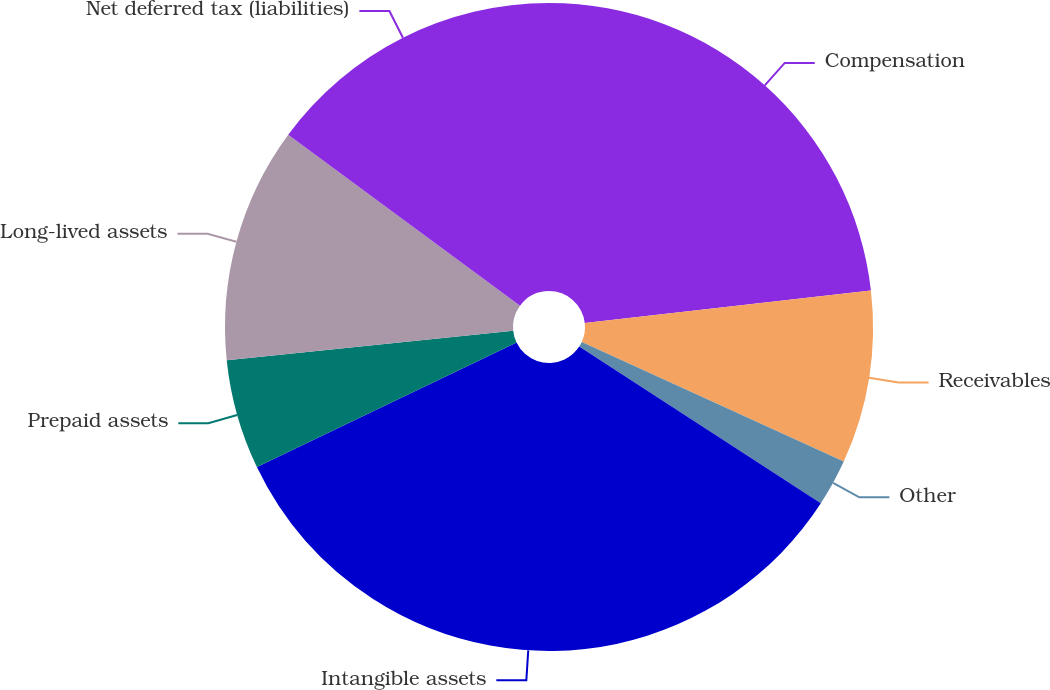Convert chart to OTSL. <chart><loc_0><loc_0><loc_500><loc_500><pie_chart><fcel>Compensation<fcel>Receivables<fcel>Other<fcel>Intangible assets<fcel>Prepaid assets<fcel>Long-lived assets<fcel>Net deferred tax (liabilities)<nl><fcel>23.2%<fcel>8.62%<fcel>2.34%<fcel>33.73%<fcel>5.48%<fcel>11.75%<fcel>14.89%<nl></chart> 